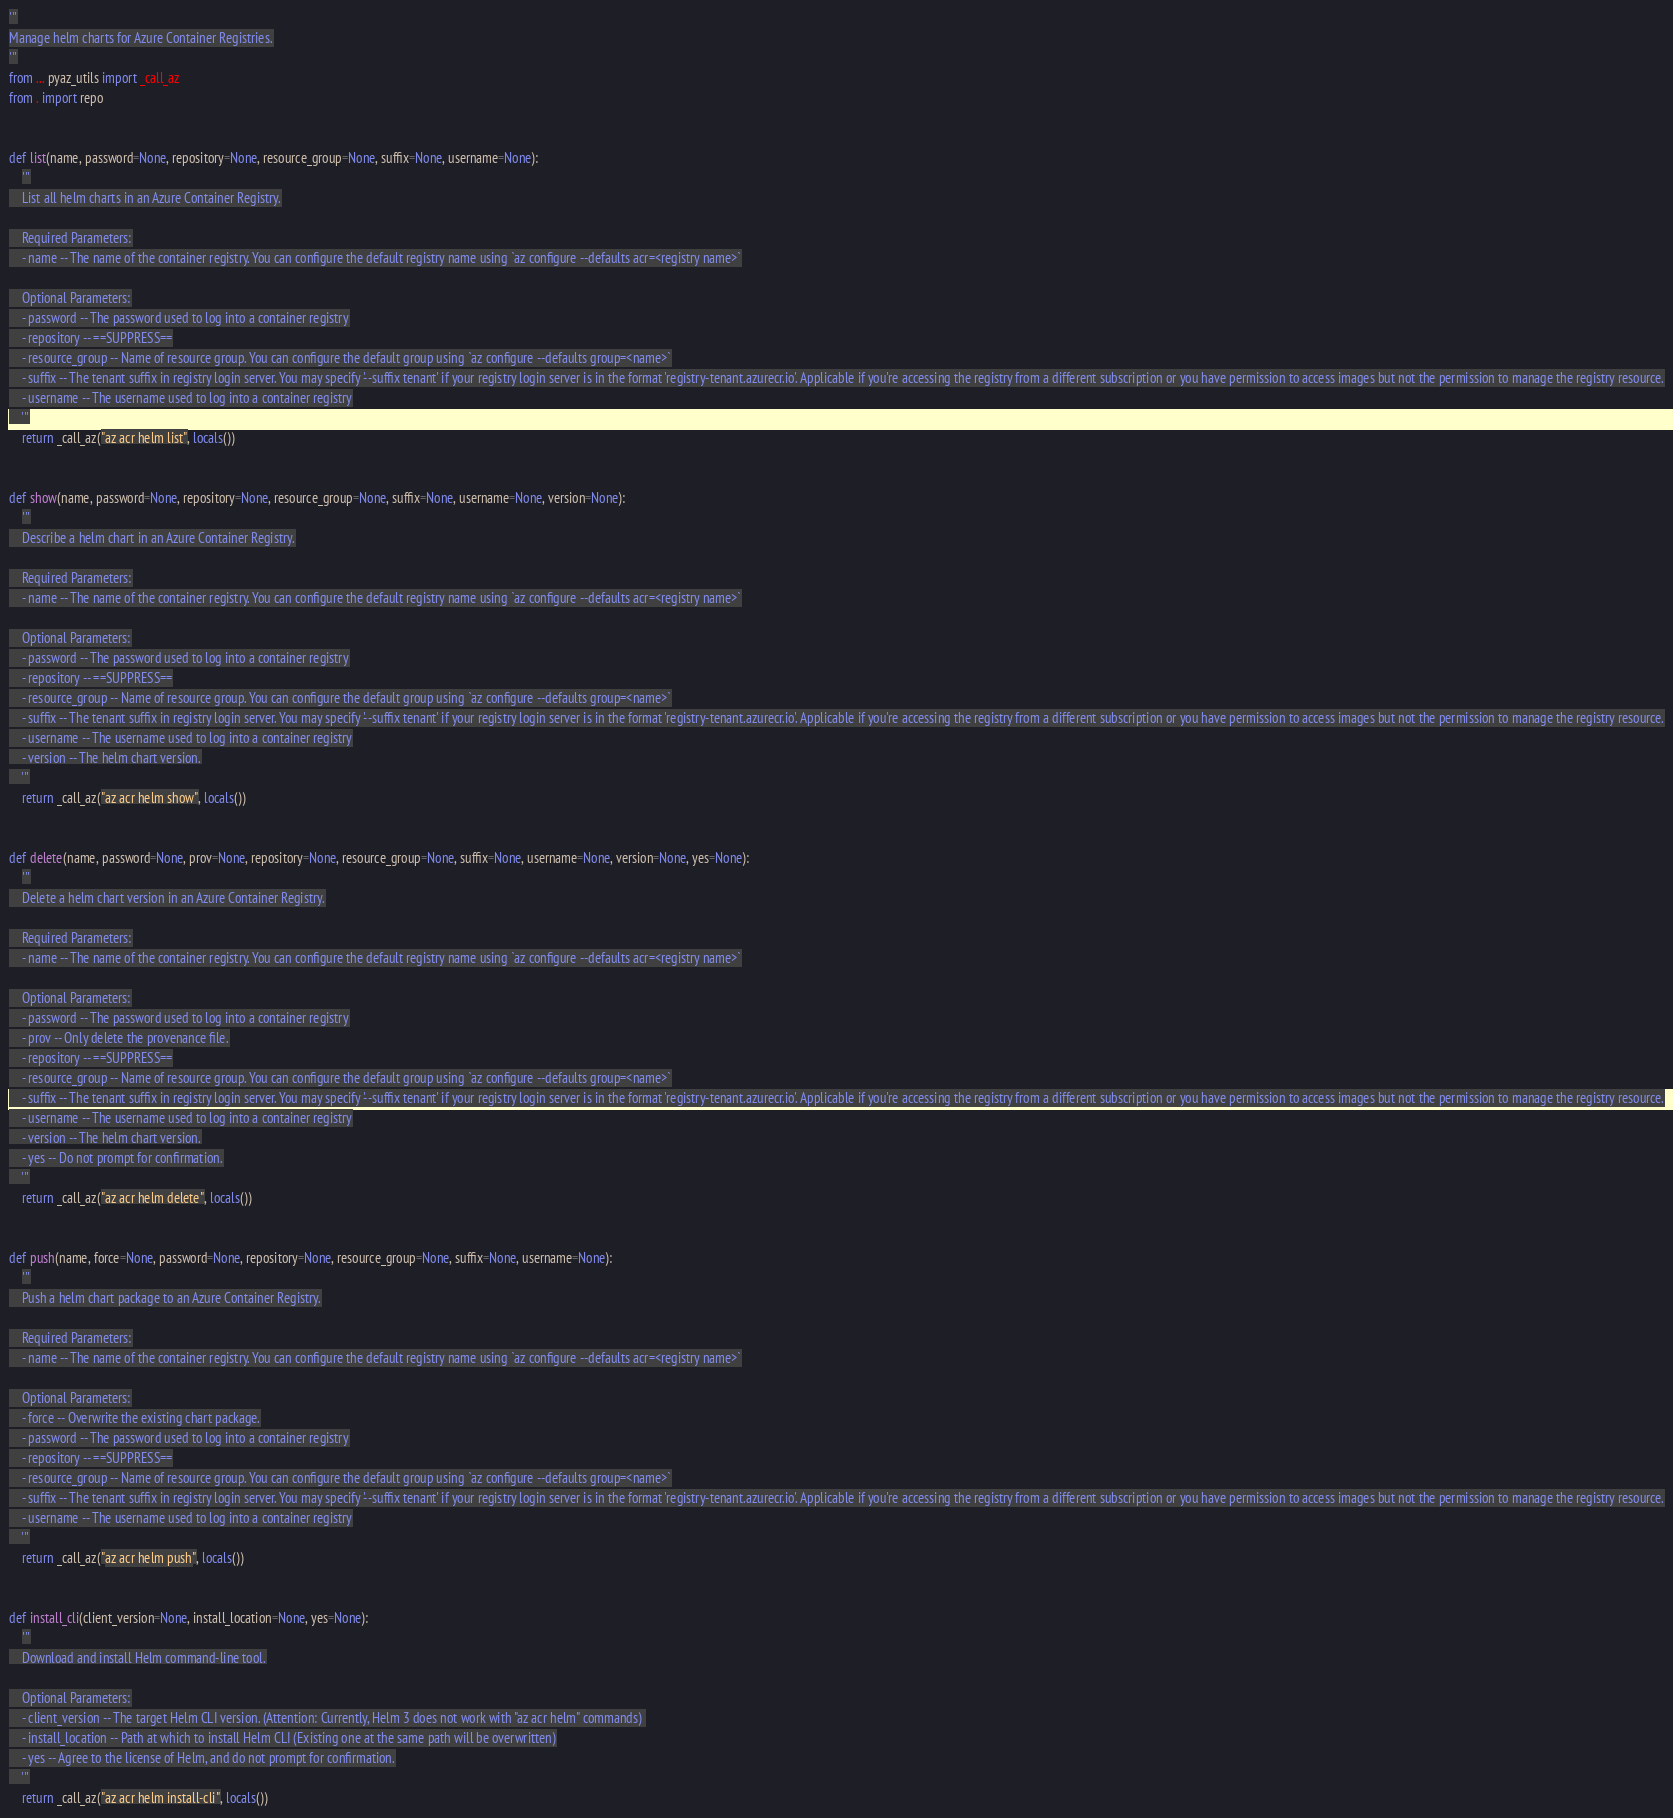Convert code to text. <code><loc_0><loc_0><loc_500><loc_500><_Python_>'''
Manage helm charts for Azure Container Registries.
'''
from ... pyaz_utils import _call_az
from . import repo


def list(name, password=None, repository=None, resource_group=None, suffix=None, username=None):
    '''
    List all helm charts in an Azure Container Registry.

    Required Parameters:
    - name -- The name of the container registry. You can configure the default registry name using `az configure --defaults acr=<registry name>`

    Optional Parameters:
    - password -- The password used to log into a container registry
    - repository -- ==SUPPRESS==
    - resource_group -- Name of resource group. You can configure the default group using `az configure --defaults group=<name>`
    - suffix -- The tenant suffix in registry login server. You may specify '--suffix tenant' if your registry login server is in the format 'registry-tenant.azurecr.io'. Applicable if you're accessing the registry from a different subscription or you have permission to access images but not the permission to manage the registry resource.
    - username -- The username used to log into a container registry
    '''
    return _call_az("az acr helm list", locals())


def show(name, password=None, repository=None, resource_group=None, suffix=None, username=None, version=None):
    '''
    Describe a helm chart in an Azure Container Registry.

    Required Parameters:
    - name -- The name of the container registry. You can configure the default registry name using `az configure --defaults acr=<registry name>`

    Optional Parameters:
    - password -- The password used to log into a container registry
    - repository -- ==SUPPRESS==
    - resource_group -- Name of resource group. You can configure the default group using `az configure --defaults group=<name>`
    - suffix -- The tenant suffix in registry login server. You may specify '--suffix tenant' if your registry login server is in the format 'registry-tenant.azurecr.io'. Applicable if you're accessing the registry from a different subscription or you have permission to access images but not the permission to manage the registry resource.
    - username -- The username used to log into a container registry
    - version -- The helm chart version.
    '''
    return _call_az("az acr helm show", locals())


def delete(name, password=None, prov=None, repository=None, resource_group=None, suffix=None, username=None, version=None, yes=None):
    '''
    Delete a helm chart version in an Azure Container Registry.

    Required Parameters:
    - name -- The name of the container registry. You can configure the default registry name using `az configure --defaults acr=<registry name>`

    Optional Parameters:
    - password -- The password used to log into a container registry
    - prov -- Only delete the provenance file.
    - repository -- ==SUPPRESS==
    - resource_group -- Name of resource group. You can configure the default group using `az configure --defaults group=<name>`
    - suffix -- The tenant suffix in registry login server. You may specify '--suffix tenant' if your registry login server is in the format 'registry-tenant.azurecr.io'. Applicable if you're accessing the registry from a different subscription or you have permission to access images but not the permission to manage the registry resource.
    - username -- The username used to log into a container registry
    - version -- The helm chart version.
    - yes -- Do not prompt for confirmation.
    '''
    return _call_az("az acr helm delete", locals())


def push(name, force=None, password=None, repository=None, resource_group=None, suffix=None, username=None):
    '''
    Push a helm chart package to an Azure Container Registry.

    Required Parameters:
    - name -- The name of the container registry. You can configure the default registry name using `az configure --defaults acr=<registry name>`

    Optional Parameters:
    - force -- Overwrite the existing chart package.
    - password -- The password used to log into a container registry
    - repository -- ==SUPPRESS==
    - resource_group -- Name of resource group. You can configure the default group using `az configure --defaults group=<name>`
    - suffix -- The tenant suffix in registry login server. You may specify '--suffix tenant' if your registry login server is in the format 'registry-tenant.azurecr.io'. Applicable if you're accessing the registry from a different subscription or you have permission to access images but not the permission to manage the registry resource.
    - username -- The username used to log into a container registry
    '''
    return _call_az("az acr helm push", locals())


def install_cli(client_version=None, install_location=None, yes=None):
    '''
    Download and install Helm command-line tool.

    Optional Parameters:
    - client_version -- The target Helm CLI version. (Attention: Currently, Helm 3 does not work with "az acr helm" commands) 
    - install_location -- Path at which to install Helm CLI (Existing one at the same path will be overwritten)
    - yes -- Agree to the license of Helm, and do not prompt for confirmation.
    '''
    return _call_az("az acr helm install-cli", locals())

</code> 